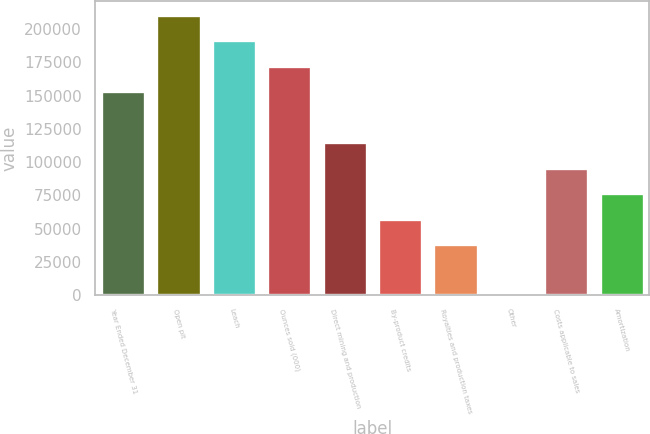Convert chart. <chart><loc_0><loc_0><loc_500><loc_500><bar_chart><fcel>Year Ended December 31<fcel>Open pit<fcel>Leach<fcel>Ounces sold (000)<fcel>Direct mining and production<fcel>By-product credits<fcel>Royalties and production taxes<fcel>Other<fcel>Costs applicable to sales<fcel>Amortization<nl><fcel>153151<fcel>210582<fcel>191438<fcel>172294<fcel>114864<fcel>57433.5<fcel>38290<fcel>3<fcel>95720.5<fcel>76577<nl></chart> 